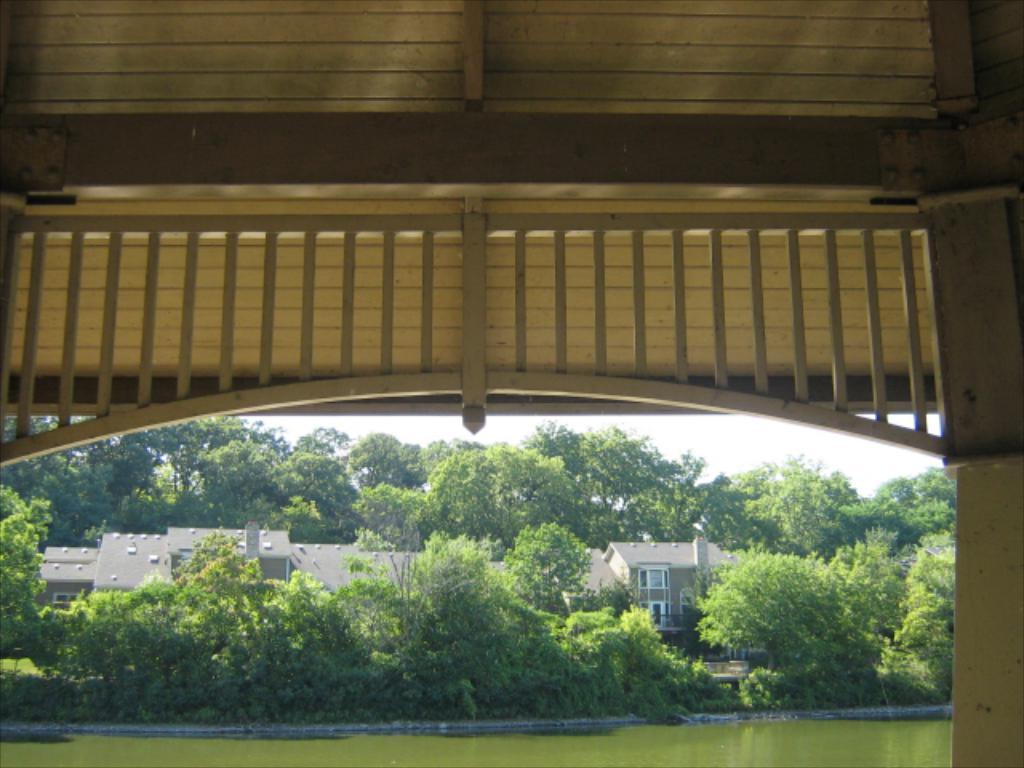Describe this image in one or two sentences. In the image we can see building and these are the windows of the building. There are many trees, this is a water, wooden fence and a sky. 